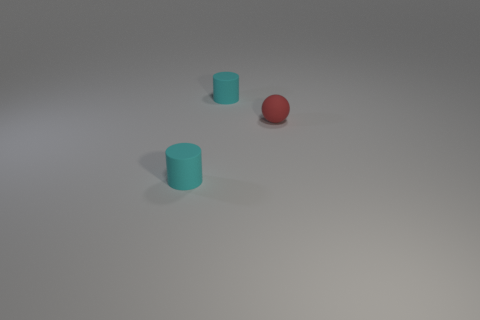What number of small objects are cyan objects or green metallic cylinders?
Provide a short and direct response. 2. There is a red thing; what shape is it?
Your response must be concise. Sphere. Is there a purple block made of the same material as the sphere?
Your response must be concise. No. Is the number of large green cubes greater than the number of small matte objects?
Your answer should be very brief. No. How many shiny objects are either spheres or cylinders?
Provide a succinct answer. 0. What number of other red matte objects have the same shape as the tiny red matte thing?
Give a very brief answer. 0. How many cubes are either cyan objects or small red objects?
Make the answer very short. 0. There is a cyan rubber object in front of the red matte ball; is its shape the same as the object behind the red rubber sphere?
Your answer should be very brief. Yes. What material is the small red sphere?
Give a very brief answer. Rubber. How many cyan rubber cylinders have the same size as the red rubber sphere?
Your answer should be compact. 2. 